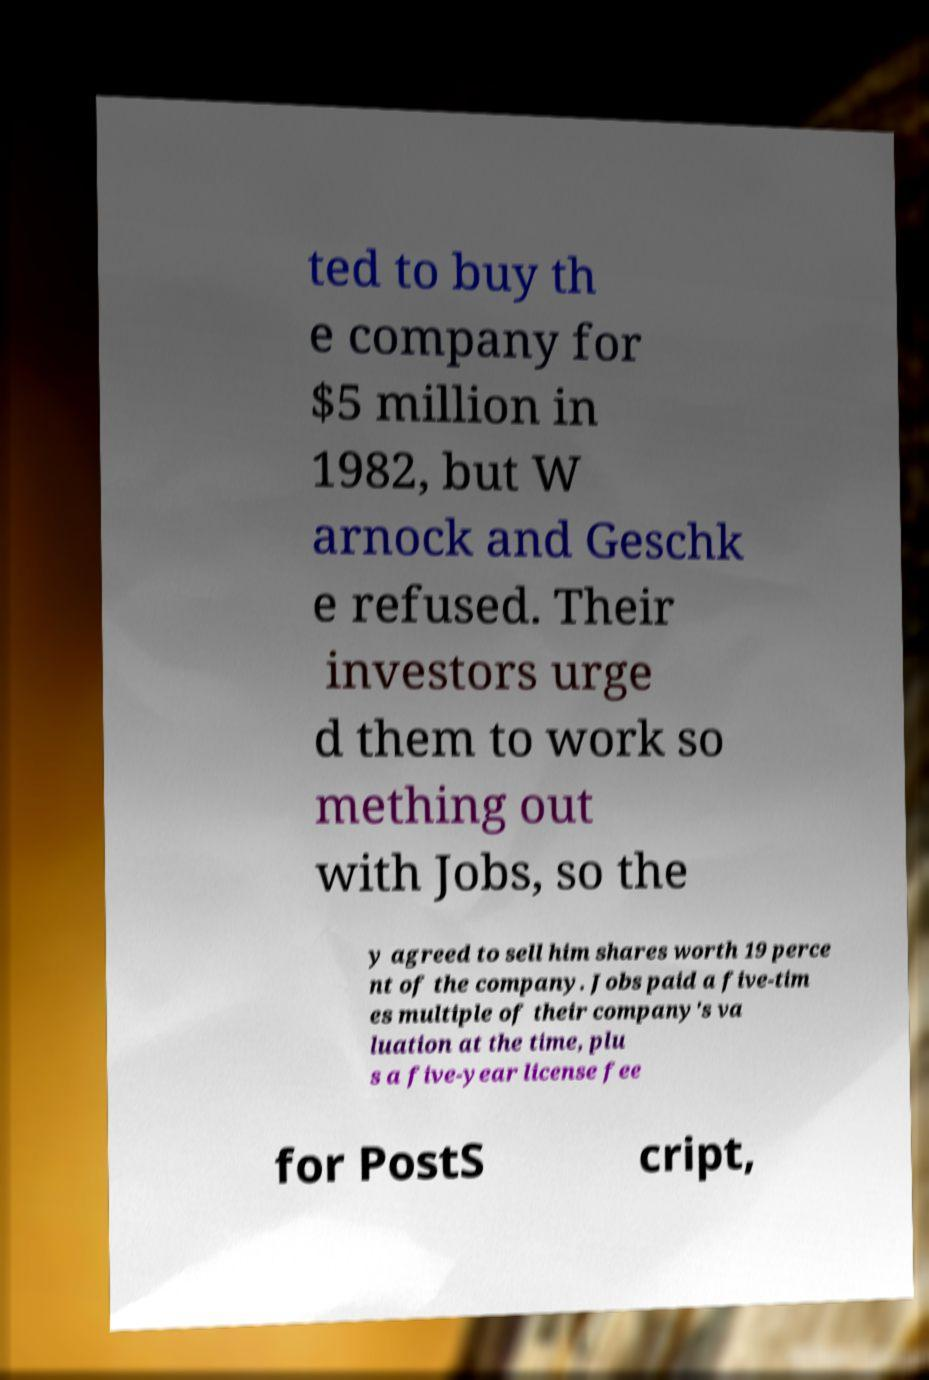I need the written content from this picture converted into text. Can you do that? ted to buy th e company for $5 million in 1982, but W arnock and Geschk e refused. Their investors urge d them to work so mething out with Jobs, so the y agreed to sell him shares worth 19 perce nt of the company. Jobs paid a five-tim es multiple of their company's va luation at the time, plu s a five-year license fee for PostS cript, 